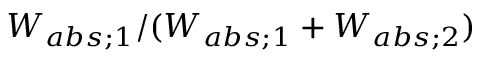Convert formula to latex. <formula><loc_0><loc_0><loc_500><loc_500>W _ { a b s ; 1 } / ( W _ { a b s ; 1 } + W _ { a b s ; 2 } )</formula> 